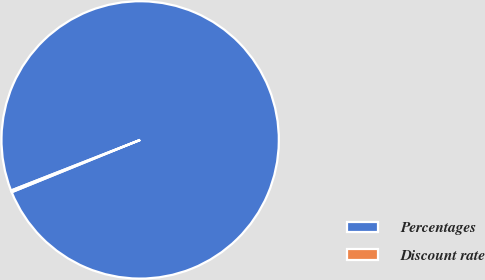Convert chart to OTSL. <chart><loc_0><loc_0><loc_500><loc_500><pie_chart><fcel>Percentages<fcel>Discount rate<nl><fcel>99.79%<fcel>0.21%<nl></chart> 